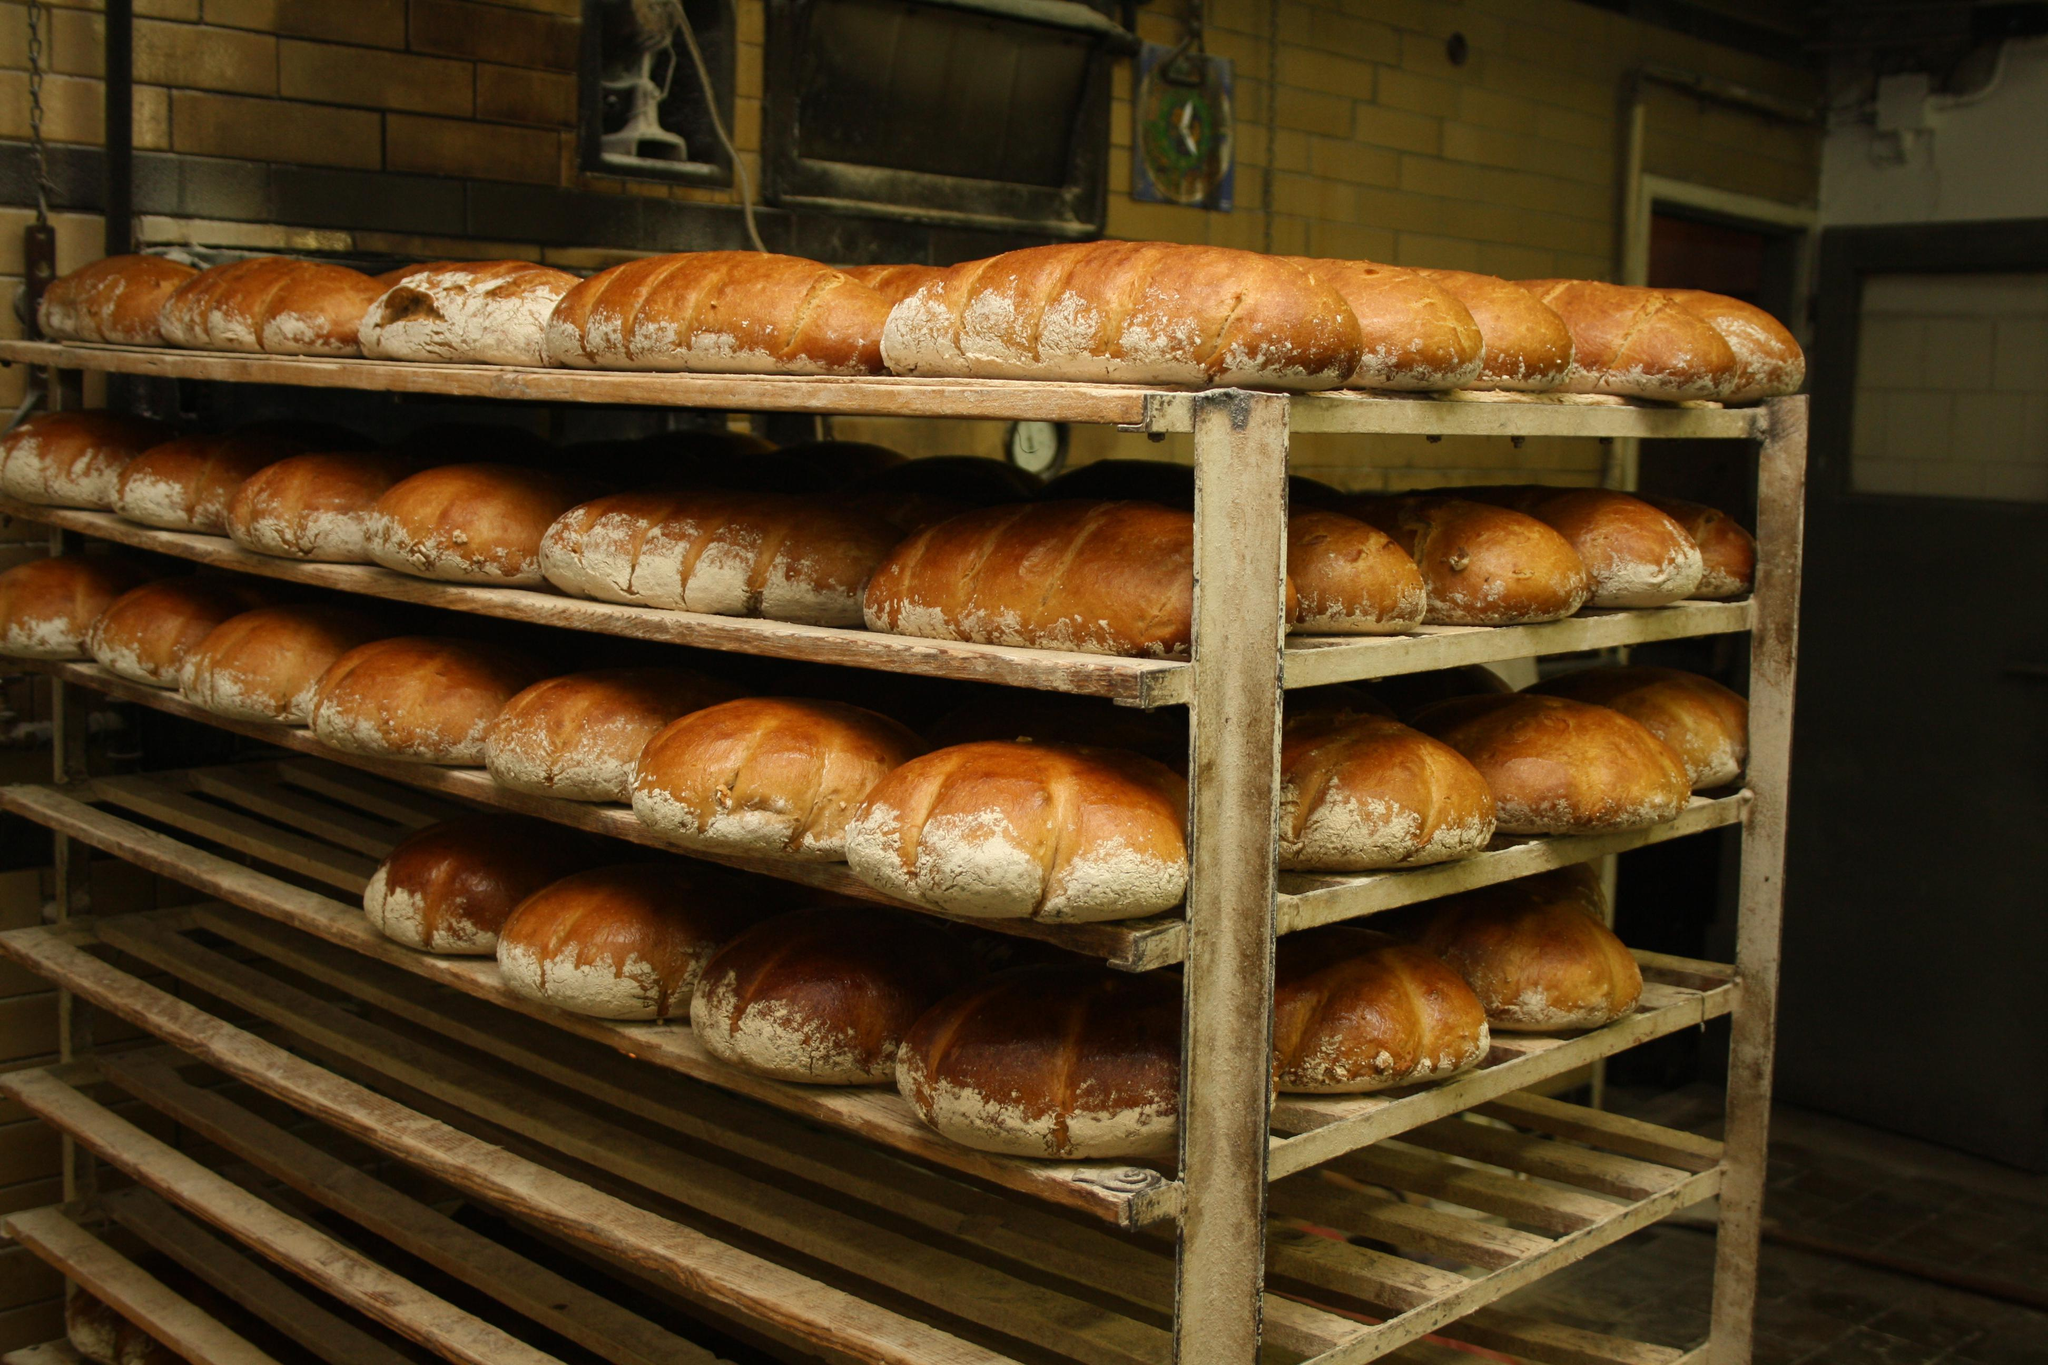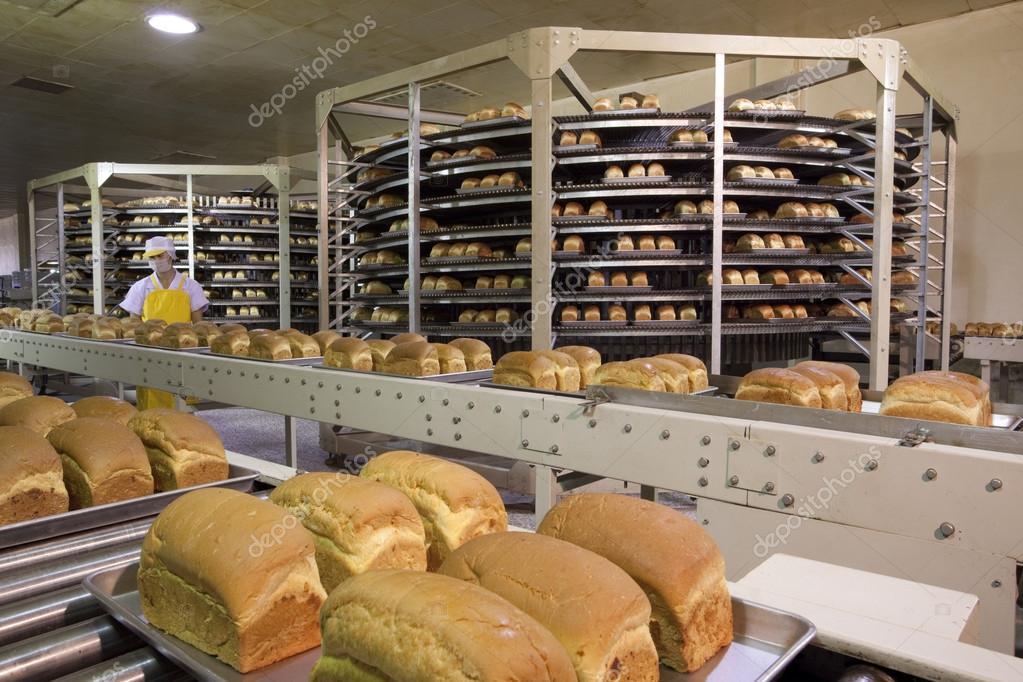The first image is the image on the left, the second image is the image on the right. For the images shown, is this caption "The right image shows a smiling man in a white shirt bending forward by racks of bread." true? Answer yes or no. No. The first image is the image on the left, the second image is the image on the right. For the images displayed, is the sentence "A baker in a white shirt and hat works in the kitchen in one of the images." factually correct? Answer yes or no. Yes. 